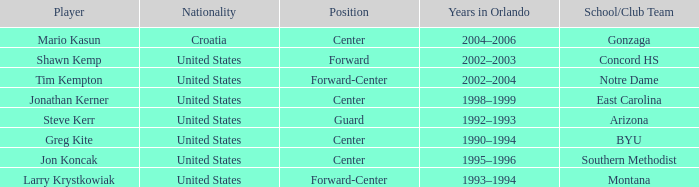Which athlete has montana as their educational/institutional team? Larry Krystkowiak. 